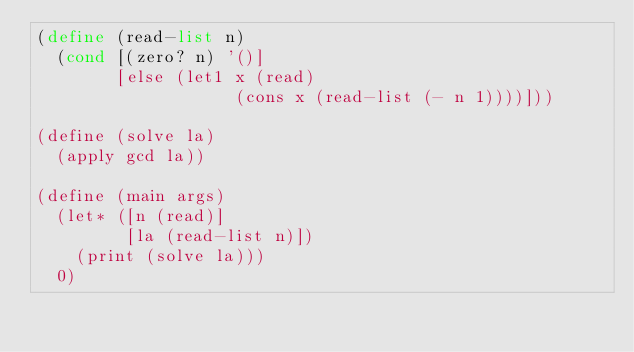Convert code to text. <code><loc_0><loc_0><loc_500><loc_500><_Scheme_>(define (read-list n)
  (cond [(zero? n) '()]
        [else (let1 x (read)
                    (cons x (read-list (- n 1))))]))

(define (solve la)
  (apply gcd la))

(define (main args)
  (let* ([n (read)]
         [la (read-list n)])
    (print (solve la)))
  0)
</code> 